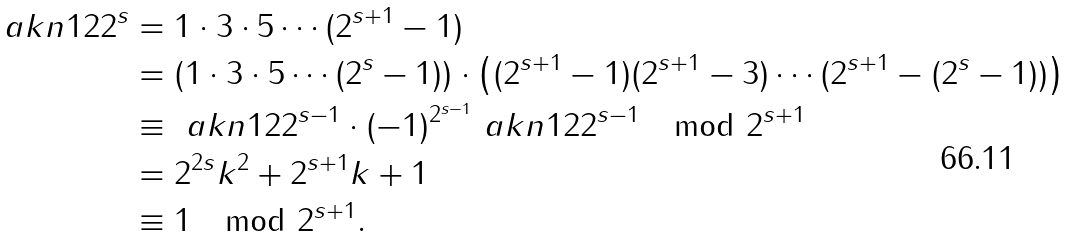<formula> <loc_0><loc_0><loc_500><loc_500>\ a k n { 1 } { 2 } { 2 ^ { s } } & = 1 \cdot 3 \cdot 5 \cdots ( 2 ^ { s + 1 } - 1 ) \\ & = \left ( 1 \cdot 3 \cdot 5 \cdots ( 2 ^ { s } - 1 ) \right ) \cdot \left ( ( 2 ^ { s + 1 } - 1 ) ( 2 ^ { s + 1 } - 3 ) \cdots ( 2 ^ { s + 1 } - ( 2 ^ { s } - 1 ) ) \right ) \\ & \equiv \ a k n { 1 } { 2 } { 2 ^ { s - 1 } } \cdot ( - 1 ) ^ { 2 ^ { s - 1 } } \ a k n { 1 } { 2 } { 2 ^ { s - 1 } } \mod 2 ^ { s + 1 } \\ & = 2 ^ { 2 s } k ^ { 2 } + 2 ^ { s + 1 } k + 1 \\ & \equiv 1 \mod 2 ^ { s + 1 } .</formula> 